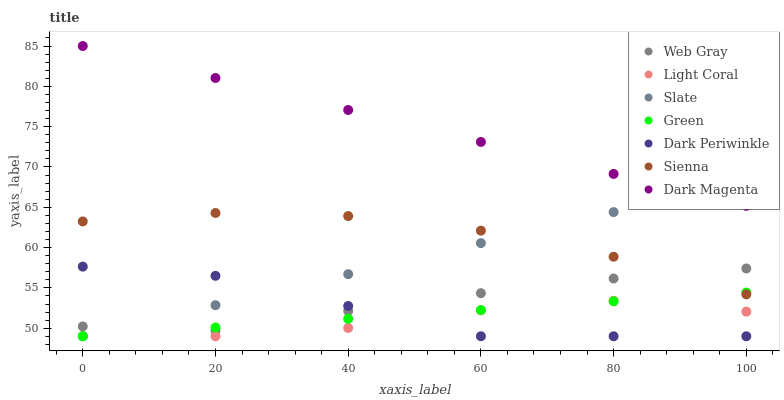Does Light Coral have the minimum area under the curve?
Answer yes or no. Yes. Does Dark Magenta have the maximum area under the curve?
Answer yes or no. Yes. Does Web Gray have the minimum area under the curve?
Answer yes or no. No. Does Web Gray have the maximum area under the curve?
Answer yes or no. No. Is Slate the smoothest?
Answer yes or no. Yes. Is Dark Periwinkle the roughest?
Answer yes or no. Yes. Is Web Gray the smoothest?
Answer yes or no. No. Is Web Gray the roughest?
Answer yes or no. No. Does Slate have the lowest value?
Answer yes or no. Yes. Does Web Gray have the lowest value?
Answer yes or no. No. Does Dark Magenta have the highest value?
Answer yes or no. Yes. Does Web Gray have the highest value?
Answer yes or no. No. Is Sienna less than Dark Magenta?
Answer yes or no. Yes. Is Dark Magenta greater than Green?
Answer yes or no. Yes. Does Green intersect Web Gray?
Answer yes or no. Yes. Is Green less than Web Gray?
Answer yes or no. No. Is Green greater than Web Gray?
Answer yes or no. No. Does Sienna intersect Dark Magenta?
Answer yes or no. No. 